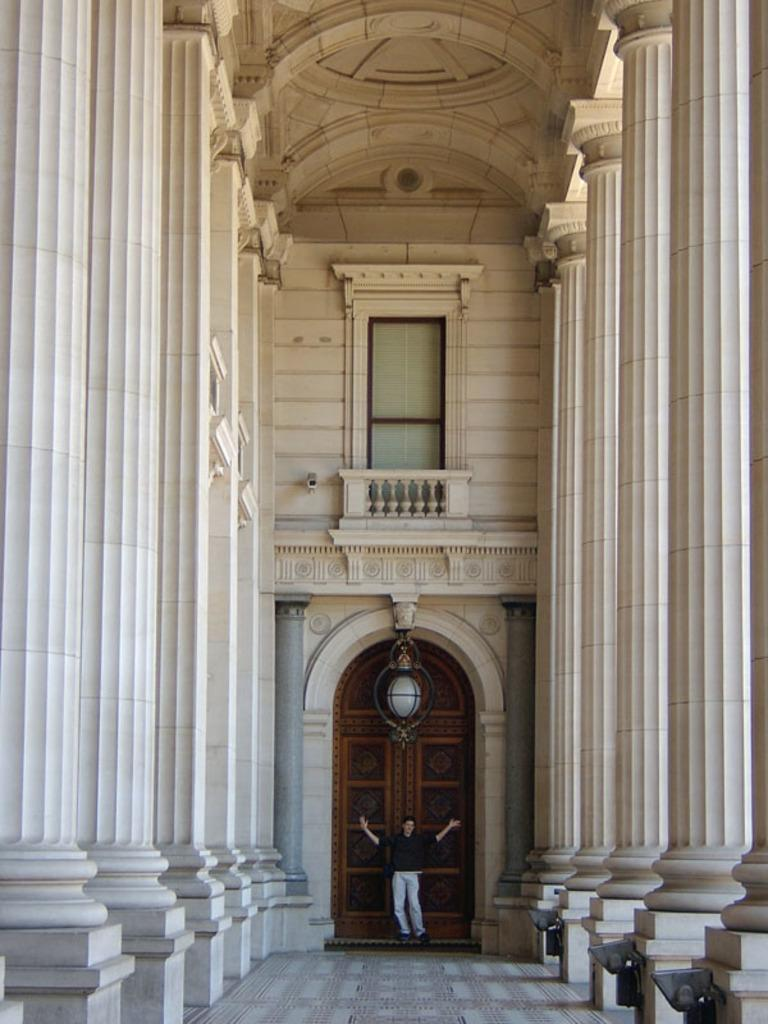What is the main subject in the image? There is a person standing in the image. What architectural features can be seen in the image? There are pillars and balusters in the image. What type of entrance is present in the image? There are doors in the image. What source of illumination is visible in the image? There is a light in the image. Are there any other objects present in the image besides the person and architectural features? Yes, there are other objects in the image. Can you see a goldfish swimming near the person in the image? No, there is no goldfish present in the image. Is there a receipt visible on the ground in the image? No, there is no receipt visible in the image. 